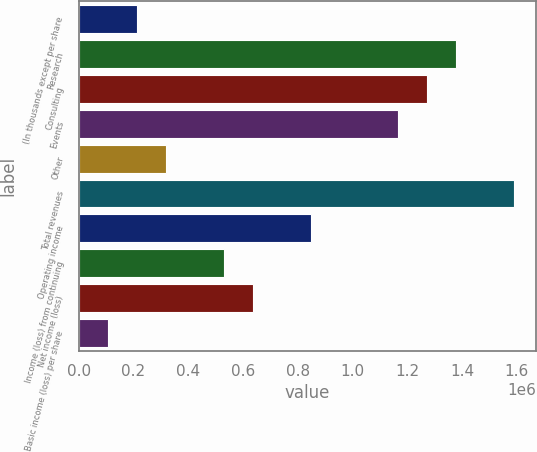Convert chart. <chart><loc_0><loc_0><loc_500><loc_500><bar_chart><fcel>(In thousands except per share<fcel>Research<fcel>Consulting<fcel>Events<fcel>Other<fcel>Total revenues<fcel>Operating income<fcel>Income (loss) from continuing<fcel>Net income (loss)<fcel>Basic income (loss) per share<nl><fcel>212065<fcel>1.37842e+06<fcel>1.27239e+06<fcel>1.16635e+06<fcel>318097<fcel>1.59048e+06<fcel>848257<fcel>530161<fcel>636193<fcel>106033<nl></chart> 